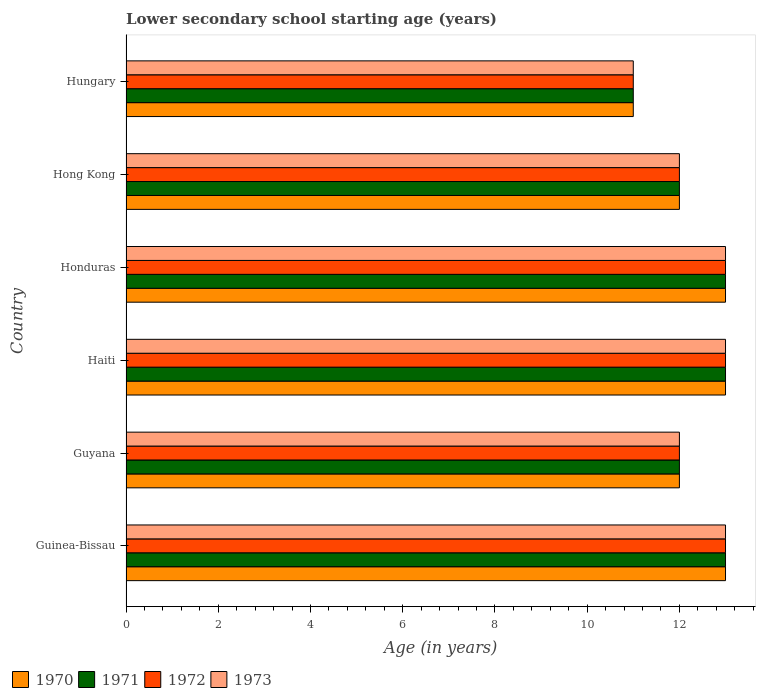Are the number of bars per tick equal to the number of legend labels?
Your response must be concise. Yes. Are the number of bars on each tick of the Y-axis equal?
Provide a succinct answer. Yes. What is the label of the 3rd group of bars from the top?
Your answer should be compact. Honduras. In how many cases, is the number of bars for a given country not equal to the number of legend labels?
Provide a short and direct response. 0. Across all countries, what is the maximum lower secondary school starting age of children in 1971?
Offer a very short reply. 13. Across all countries, what is the minimum lower secondary school starting age of children in 1973?
Offer a terse response. 11. In which country was the lower secondary school starting age of children in 1972 maximum?
Offer a very short reply. Guinea-Bissau. In which country was the lower secondary school starting age of children in 1973 minimum?
Provide a succinct answer. Hungary. What is the total lower secondary school starting age of children in 1970 in the graph?
Your response must be concise. 74. What is the average lower secondary school starting age of children in 1971 per country?
Offer a very short reply. 12.33. What is the difference between the lower secondary school starting age of children in 1971 and lower secondary school starting age of children in 1973 in Haiti?
Provide a succinct answer. 0. In how many countries, is the lower secondary school starting age of children in 1972 greater than 0.4 years?
Your answer should be very brief. 6. What is the ratio of the lower secondary school starting age of children in 1973 in Guinea-Bissau to that in Hungary?
Your answer should be very brief. 1.18. Is the lower secondary school starting age of children in 1971 in Guinea-Bissau less than that in Hungary?
Offer a very short reply. No. Is the difference between the lower secondary school starting age of children in 1971 in Honduras and Hungary greater than the difference between the lower secondary school starting age of children in 1973 in Honduras and Hungary?
Make the answer very short. No. In how many countries, is the lower secondary school starting age of children in 1973 greater than the average lower secondary school starting age of children in 1973 taken over all countries?
Ensure brevity in your answer.  3. What does the 1st bar from the bottom in Honduras represents?
Ensure brevity in your answer.  1970. Is it the case that in every country, the sum of the lower secondary school starting age of children in 1971 and lower secondary school starting age of children in 1972 is greater than the lower secondary school starting age of children in 1973?
Give a very brief answer. Yes. Are all the bars in the graph horizontal?
Your response must be concise. Yes. What is the difference between two consecutive major ticks on the X-axis?
Offer a terse response. 2. Are the values on the major ticks of X-axis written in scientific E-notation?
Provide a succinct answer. No. Does the graph contain grids?
Provide a short and direct response. No. Where does the legend appear in the graph?
Offer a terse response. Bottom left. How many legend labels are there?
Offer a terse response. 4. How are the legend labels stacked?
Your answer should be compact. Horizontal. What is the title of the graph?
Your answer should be very brief. Lower secondary school starting age (years). Does "1968" appear as one of the legend labels in the graph?
Keep it short and to the point. No. What is the label or title of the X-axis?
Make the answer very short. Age (in years). What is the label or title of the Y-axis?
Offer a very short reply. Country. What is the Age (in years) in 1970 in Guinea-Bissau?
Your answer should be compact. 13. What is the Age (in years) of 1971 in Guinea-Bissau?
Provide a short and direct response. 13. What is the Age (in years) of 1972 in Guinea-Bissau?
Your answer should be compact. 13. What is the Age (in years) of 1973 in Guinea-Bissau?
Your answer should be very brief. 13. What is the Age (in years) in 1973 in Guyana?
Offer a very short reply. 12. What is the Age (in years) in 1971 in Haiti?
Keep it short and to the point. 13. What is the Age (in years) of 1972 in Haiti?
Provide a succinct answer. 13. What is the Age (in years) of 1972 in Honduras?
Your answer should be very brief. 13. What is the Age (in years) in 1973 in Honduras?
Keep it short and to the point. 13. What is the Age (in years) in 1971 in Hong Kong?
Give a very brief answer. 12. What is the Age (in years) in 1972 in Hong Kong?
Provide a short and direct response. 12. What is the Age (in years) of 1970 in Hungary?
Ensure brevity in your answer.  11. What is the Age (in years) of 1971 in Hungary?
Ensure brevity in your answer.  11. What is the Age (in years) of 1972 in Hungary?
Make the answer very short. 11. Across all countries, what is the maximum Age (in years) in 1971?
Give a very brief answer. 13. Across all countries, what is the maximum Age (in years) in 1973?
Provide a succinct answer. 13. Across all countries, what is the minimum Age (in years) in 1970?
Give a very brief answer. 11. Across all countries, what is the minimum Age (in years) in 1971?
Provide a short and direct response. 11. Across all countries, what is the minimum Age (in years) in 1972?
Provide a succinct answer. 11. What is the total Age (in years) of 1970 in the graph?
Give a very brief answer. 74. What is the total Age (in years) in 1971 in the graph?
Give a very brief answer. 74. What is the total Age (in years) of 1972 in the graph?
Provide a short and direct response. 74. What is the difference between the Age (in years) of 1970 in Guinea-Bissau and that in Guyana?
Give a very brief answer. 1. What is the difference between the Age (in years) in 1972 in Guinea-Bissau and that in Guyana?
Give a very brief answer. 1. What is the difference between the Age (in years) of 1972 in Guinea-Bissau and that in Haiti?
Give a very brief answer. 0. What is the difference between the Age (in years) of 1970 in Guinea-Bissau and that in Honduras?
Your response must be concise. 0. What is the difference between the Age (in years) of 1971 in Guinea-Bissau and that in Honduras?
Offer a terse response. 0. What is the difference between the Age (in years) of 1973 in Guinea-Bissau and that in Honduras?
Offer a terse response. 0. What is the difference between the Age (in years) in 1971 in Guinea-Bissau and that in Hong Kong?
Your answer should be very brief. 1. What is the difference between the Age (in years) in 1972 in Guinea-Bissau and that in Hong Kong?
Your response must be concise. 1. What is the difference between the Age (in years) in 1970 in Guinea-Bissau and that in Hungary?
Provide a short and direct response. 2. What is the difference between the Age (in years) in 1970 in Guyana and that in Haiti?
Your answer should be very brief. -1. What is the difference between the Age (in years) of 1971 in Guyana and that in Haiti?
Offer a terse response. -1. What is the difference between the Age (in years) of 1970 in Guyana and that in Honduras?
Your response must be concise. -1. What is the difference between the Age (in years) in 1972 in Guyana and that in Honduras?
Offer a terse response. -1. What is the difference between the Age (in years) in 1973 in Guyana and that in Honduras?
Keep it short and to the point. -1. What is the difference between the Age (in years) of 1971 in Guyana and that in Hong Kong?
Offer a very short reply. 0. What is the difference between the Age (in years) of 1973 in Guyana and that in Hong Kong?
Keep it short and to the point. 0. What is the difference between the Age (in years) of 1970 in Guyana and that in Hungary?
Ensure brevity in your answer.  1. What is the difference between the Age (in years) of 1972 in Guyana and that in Hungary?
Offer a very short reply. 1. What is the difference between the Age (in years) in 1973 in Guyana and that in Hungary?
Provide a succinct answer. 1. What is the difference between the Age (in years) in 1970 in Haiti and that in Honduras?
Offer a terse response. 0. What is the difference between the Age (in years) in 1971 in Haiti and that in Honduras?
Your response must be concise. 0. What is the difference between the Age (in years) in 1971 in Haiti and that in Hong Kong?
Offer a terse response. 1. What is the difference between the Age (in years) of 1973 in Haiti and that in Hong Kong?
Ensure brevity in your answer.  1. What is the difference between the Age (in years) of 1970 in Haiti and that in Hungary?
Make the answer very short. 2. What is the difference between the Age (in years) of 1971 in Haiti and that in Hungary?
Provide a succinct answer. 2. What is the difference between the Age (in years) in 1972 in Haiti and that in Hungary?
Your answer should be compact. 2. What is the difference between the Age (in years) of 1973 in Haiti and that in Hungary?
Provide a short and direct response. 2. What is the difference between the Age (in years) in 1971 in Honduras and that in Hong Kong?
Your response must be concise. 1. What is the difference between the Age (in years) in 1973 in Honduras and that in Hong Kong?
Offer a terse response. 1. What is the difference between the Age (in years) of 1970 in Honduras and that in Hungary?
Offer a terse response. 2. What is the difference between the Age (in years) of 1970 in Hong Kong and that in Hungary?
Offer a terse response. 1. What is the difference between the Age (in years) of 1971 in Hong Kong and that in Hungary?
Your answer should be compact. 1. What is the difference between the Age (in years) of 1970 in Guinea-Bissau and the Age (in years) of 1971 in Guyana?
Your response must be concise. 1. What is the difference between the Age (in years) of 1970 in Guinea-Bissau and the Age (in years) of 1973 in Guyana?
Give a very brief answer. 1. What is the difference between the Age (in years) of 1971 in Guinea-Bissau and the Age (in years) of 1973 in Guyana?
Provide a short and direct response. 1. What is the difference between the Age (in years) of 1972 in Guinea-Bissau and the Age (in years) of 1973 in Guyana?
Give a very brief answer. 1. What is the difference between the Age (in years) in 1971 in Guinea-Bissau and the Age (in years) in 1973 in Haiti?
Give a very brief answer. 0. What is the difference between the Age (in years) of 1970 in Guinea-Bissau and the Age (in years) of 1971 in Honduras?
Your response must be concise. 0. What is the difference between the Age (in years) of 1970 in Guinea-Bissau and the Age (in years) of 1973 in Honduras?
Your answer should be compact. 0. What is the difference between the Age (in years) in 1970 in Guinea-Bissau and the Age (in years) in 1972 in Hong Kong?
Offer a very short reply. 1. What is the difference between the Age (in years) of 1970 in Guinea-Bissau and the Age (in years) of 1973 in Hong Kong?
Your answer should be compact. 1. What is the difference between the Age (in years) in 1972 in Guinea-Bissau and the Age (in years) in 1973 in Hong Kong?
Offer a very short reply. 1. What is the difference between the Age (in years) in 1970 in Guinea-Bissau and the Age (in years) in 1971 in Hungary?
Provide a short and direct response. 2. What is the difference between the Age (in years) of 1970 in Guinea-Bissau and the Age (in years) of 1972 in Hungary?
Your answer should be compact. 2. What is the difference between the Age (in years) of 1970 in Guinea-Bissau and the Age (in years) of 1973 in Hungary?
Offer a very short reply. 2. What is the difference between the Age (in years) of 1971 in Guinea-Bissau and the Age (in years) of 1972 in Hungary?
Make the answer very short. 2. What is the difference between the Age (in years) in 1970 in Guyana and the Age (in years) in 1972 in Haiti?
Ensure brevity in your answer.  -1. What is the difference between the Age (in years) of 1970 in Guyana and the Age (in years) of 1973 in Haiti?
Make the answer very short. -1. What is the difference between the Age (in years) of 1971 in Guyana and the Age (in years) of 1973 in Haiti?
Make the answer very short. -1. What is the difference between the Age (in years) of 1970 in Guyana and the Age (in years) of 1971 in Honduras?
Your answer should be compact. -1. What is the difference between the Age (in years) of 1971 in Guyana and the Age (in years) of 1972 in Honduras?
Your response must be concise. -1. What is the difference between the Age (in years) of 1971 in Guyana and the Age (in years) of 1973 in Honduras?
Keep it short and to the point. -1. What is the difference between the Age (in years) of 1970 in Guyana and the Age (in years) of 1972 in Hong Kong?
Give a very brief answer. 0. What is the difference between the Age (in years) in 1970 in Guyana and the Age (in years) in 1973 in Hong Kong?
Keep it short and to the point. 0. What is the difference between the Age (in years) in 1971 in Guyana and the Age (in years) in 1973 in Hong Kong?
Provide a short and direct response. 0. What is the difference between the Age (in years) in 1970 in Guyana and the Age (in years) in 1972 in Hungary?
Give a very brief answer. 1. What is the difference between the Age (in years) in 1970 in Guyana and the Age (in years) in 1973 in Hungary?
Keep it short and to the point. 1. What is the difference between the Age (in years) of 1971 in Guyana and the Age (in years) of 1972 in Hungary?
Provide a succinct answer. 1. What is the difference between the Age (in years) in 1971 in Guyana and the Age (in years) in 1973 in Hungary?
Give a very brief answer. 1. What is the difference between the Age (in years) in 1970 in Haiti and the Age (in years) in 1972 in Honduras?
Ensure brevity in your answer.  0. What is the difference between the Age (in years) of 1970 in Haiti and the Age (in years) of 1973 in Honduras?
Your response must be concise. 0. What is the difference between the Age (in years) in 1971 in Haiti and the Age (in years) in 1973 in Honduras?
Offer a terse response. 0. What is the difference between the Age (in years) in 1972 in Haiti and the Age (in years) in 1973 in Honduras?
Make the answer very short. 0. What is the difference between the Age (in years) in 1970 in Haiti and the Age (in years) in 1972 in Hong Kong?
Provide a succinct answer. 1. What is the difference between the Age (in years) in 1971 in Haiti and the Age (in years) in 1972 in Hong Kong?
Offer a terse response. 1. What is the difference between the Age (in years) in 1972 in Haiti and the Age (in years) in 1973 in Hong Kong?
Provide a short and direct response. 1. What is the difference between the Age (in years) in 1970 in Haiti and the Age (in years) in 1971 in Hungary?
Provide a succinct answer. 2. What is the difference between the Age (in years) of 1970 in Haiti and the Age (in years) of 1973 in Hungary?
Your response must be concise. 2. What is the difference between the Age (in years) in 1970 in Honduras and the Age (in years) in 1971 in Hong Kong?
Ensure brevity in your answer.  1. What is the difference between the Age (in years) in 1970 in Honduras and the Age (in years) in 1972 in Hong Kong?
Your answer should be compact. 1. What is the difference between the Age (in years) in 1970 in Honduras and the Age (in years) in 1973 in Hong Kong?
Offer a terse response. 1. What is the difference between the Age (in years) of 1971 in Honduras and the Age (in years) of 1973 in Hong Kong?
Offer a very short reply. 1. What is the difference between the Age (in years) in 1972 in Honduras and the Age (in years) in 1973 in Hong Kong?
Give a very brief answer. 1. What is the difference between the Age (in years) in 1970 in Hong Kong and the Age (in years) in 1972 in Hungary?
Ensure brevity in your answer.  1. What is the difference between the Age (in years) of 1971 in Hong Kong and the Age (in years) of 1973 in Hungary?
Offer a very short reply. 1. What is the average Age (in years) in 1970 per country?
Offer a very short reply. 12.33. What is the average Age (in years) of 1971 per country?
Offer a terse response. 12.33. What is the average Age (in years) in 1972 per country?
Your answer should be very brief. 12.33. What is the average Age (in years) of 1973 per country?
Your answer should be compact. 12.33. What is the difference between the Age (in years) of 1971 and Age (in years) of 1973 in Guinea-Bissau?
Offer a very short reply. 0. What is the difference between the Age (in years) of 1972 and Age (in years) of 1973 in Guinea-Bissau?
Your answer should be very brief. 0. What is the difference between the Age (in years) of 1970 and Age (in years) of 1972 in Guyana?
Offer a very short reply. 0. What is the difference between the Age (in years) in 1971 and Age (in years) in 1972 in Guyana?
Your answer should be compact. 0. What is the difference between the Age (in years) of 1971 and Age (in years) of 1973 in Guyana?
Your response must be concise. 0. What is the difference between the Age (in years) of 1970 and Age (in years) of 1971 in Haiti?
Offer a terse response. 0. What is the difference between the Age (in years) in 1970 and Age (in years) in 1973 in Haiti?
Your response must be concise. 0. What is the difference between the Age (in years) in 1972 and Age (in years) in 1973 in Haiti?
Your response must be concise. 0. What is the difference between the Age (in years) in 1970 and Age (in years) in 1971 in Honduras?
Your answer should be compact. 0. What is the difference between the Age (in years) of 1970 and Age (in years) of 1973 in Honduras?
Offer a very short reply. 0. What is the difference between the Age (in years) in 1972 and Age (in years) in 1973 in Honduras?
Keep it short and to the point. 0. What is the difference between the Age (in years) of 1970 and Age (in years) of 1971 in Hong Kong?
Ensure brevity in your answer.  0. What is the difference between the Age (in years) in 1971 and Age (in years) in 1972 in Hong Kong?
Your response must be concise. 0. What is the difference between the Age (in years) in 1971 and Age (in years) in 1973 in Hong Kong?
Your answer should be very brief. 0. What is the difference between the Age (in years) of 1970 and Age (in years) of 1971 in Hungary?
Offer a very short reply. 0. What is the difference between the Age (in years) of 1970 and Age (in years) of 1972 in Hungary?
Keep it short and to the point. 0. What is the ratio of the Age (in years) in 1973 in Guinea-Bissau to that in Guyana?
Provide a short and direct response. 1.08. What is the ratio of the Age (in years) of 1971 in Guinea-Bissau to that in Haiti?
Provide a short and direct response. 1. What is the ratio of the Age (in years) in 1972 in Guinea-Bissau to that in Haiti?
Make the answer very short. 1. What is the ratio of the Age (in years) of 1973 in Guinea-Bissau to that in Haiti?
Your answer should be compact. 1. What is the ratio of the Age (in years) in 1970 in Guinea-Bissau to that in Honduras?
Offer a terse response. 1. What is the ratio of the Age (in years) of 1970 in Guinea-Bissau to that in Hong Kong?
Make the answer very short. 1.08. What is the ratio of the Age (in years) in 1971 in Guinea-Bissau to that in Hong Kong?
Provide a short and direct response. 1.08. What is the ratio of the Age (in years) in 1972 in Guinea-Bissau to that in Hong Kong?
Give a very brief answer. 1.08. What is the ratio of the Age (in years) of 1970 in Guinea-Bissau to that in Hungary?
Give a very brief answer. 1.18. What is the ratio of the Age (in years) of 1971 in Guinea-Bissau to that in Hungary?
Your answer should be very brief. 1.18. What is the ratio of the Age (in years) of 1972 in Guinea-Bissau to that in Hungary?
Keep it short and to the point. 1.18. What is the ratio of the Age (in years) in 1973 in Guinea-Bissau to that in Hungary?
Offer a terse response. 1.18. What is the ratio of the Age (in years) of 1971 in Guyana to that in Haiti?
Keep it short and to the point. 0.92. What is the ratio of the Age (in years) of 1972 in Guyana to that in Haiti?
Provide a succinct answer. 0.92. What is the ratio of the Age (in years) in 1973 in Guyana to that in Haiti?
Your answer should be compact. 0.92. What is the ratio of the Age (in years) in 1971 in Guyana to that in Honduras?
Offer a terse response. 0.92. What is the ratio of the Age (in years) of 1972 in Guyana to that in Honduras?
Ensure brevity in your answer.  0.92. What is the ratio of the Age (in years) in 1972 in Guyana to that in Hong Kong?
Ensure brevity in your answer.  1. What is the ratio of the Age (in years) of 1973 in Guyana to that in Hong Kong?
Provide a succinct answer. 1. What is the ratio of the Age (in years) in 1971 in Guyana to that in Hungary?
Provide a succinct answer. 1.09. What is the ratio of the Age (in years) in 1972 in Guyana to that in Hungary?
Keep it short and to the point. 1.09. What is the ratio of the Age (in years) of 1973 in Guyana to that in Hungary?
Your response must be concise. 1.09. What is the ratio of the Age (in years) in 1970 in Haiti to that in Honduras?
Ensure brevity in your answer.  1. What is the ratio of the Age (in years) in 1971 in Haiti to that in Honduras?
Your answer should be compact. 1. What is the ratio of the Age (in years) of 1972 in Haiti to that in Honduras?
Keep it short and to the point. 1. What is the ratio of the Age (in years) of 1970 in Haiti to that in Hong Kong?
Provide a short and direct response. 1.08. What is the ratio of the Age (in years) in 1971 in Haiti to that in Hong Kong?
Your answer should be compact. 1.08. What is the ratio of the Age (in years) in 1973 in Haiti to that in Hong Kong?
Make the answer very short. 1.08. What is the ratio of the Age (in years) in 1970 in Haiti to that in Hungary?
Provide a short and direct response. 1.18. What is the ratio of the Age (in years) of 1971 in Haiti to that in Hungary?
Provide a short and direct response. 1.18. What is the ratio of the Age (in years) of 1972 in Haiti to that in Hungary?
Offer a very short reply. 1.18. What is the ratio of the Age (in years) of 1973 in Haiti to that in Hungary?
Offer a terse response. 1.18. What is the ratio of the Age (in years) of 1972 in Honduras to that in Hong Kong?
Provide a succinct answer. 1.08. What is the ratio of the Age (in years) of 1973 in Honduras to that in Hong Kong?
Provide a short and direct response. 1.08. What is the ratio of the Age (in years) in 1970 in Honduras to that in Hungary?
Provide a succinct answer. 1.18. What is the ratio of the Age (in years) of 1971 in Honduras to that in Hungary?
Offer a very short reply. 1.18. What is the ratio of the Age (in years) of 1972 in Honduras to that in Hungary?
Your response must be concise. 1.18. What is the ratio of the Age (in years) of 1973 in Honduras to that in Hungary?
Your answer should be very brief. 1.18. What is the ratio of the Age (in years) in 1971 in Hong Kong to that in Hungary?
Ensure brevity in your answer.  1.09. What is the ratio of the Age (in years) in 1972 in Hong Kong to that in Hungary?
Your answer should be compact. 1.09. What is the ratio of the Age (in years) in 1973 in Hong Kong to that in Hungary?
Provide a short and direct response. 1.09. What is the difference between the highest and the second highest Age (in years) in 1970?
Offer a terse response. 0. What is the difference between the highest and the second highest Age (in years) in 1971?
Offer a very short reply. 0. 